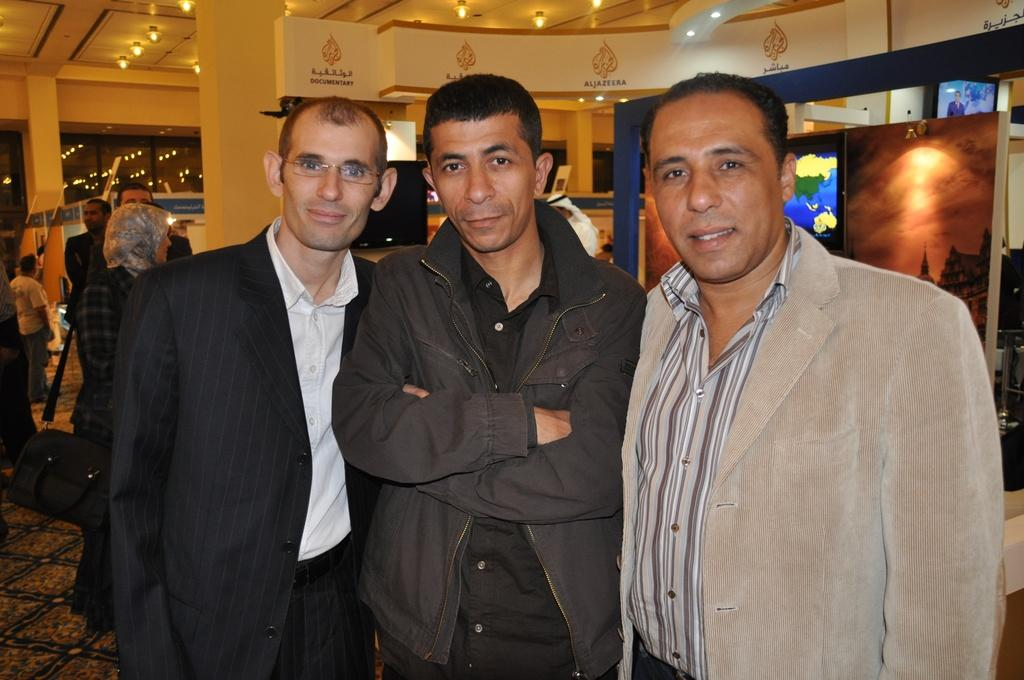What can be seen in the image? There are people standing in the image, along with painting portraits and lights. Where are the people standing? The people are standing on the floor. How are the painting portraits displayed? The painting portraits are kept on a stand. Can you describe the lights in the image? The lights are visible in the image, and they are on the top. What type of doctor can be seen treating the bushes in the image? There are no doctors or bushes present in the image; it features people standing near painting portraits and lights. What type of punishment is being given to the people in the image? There is no indication of punishment in the image; the people are simply standing near painting portraits and lights. 